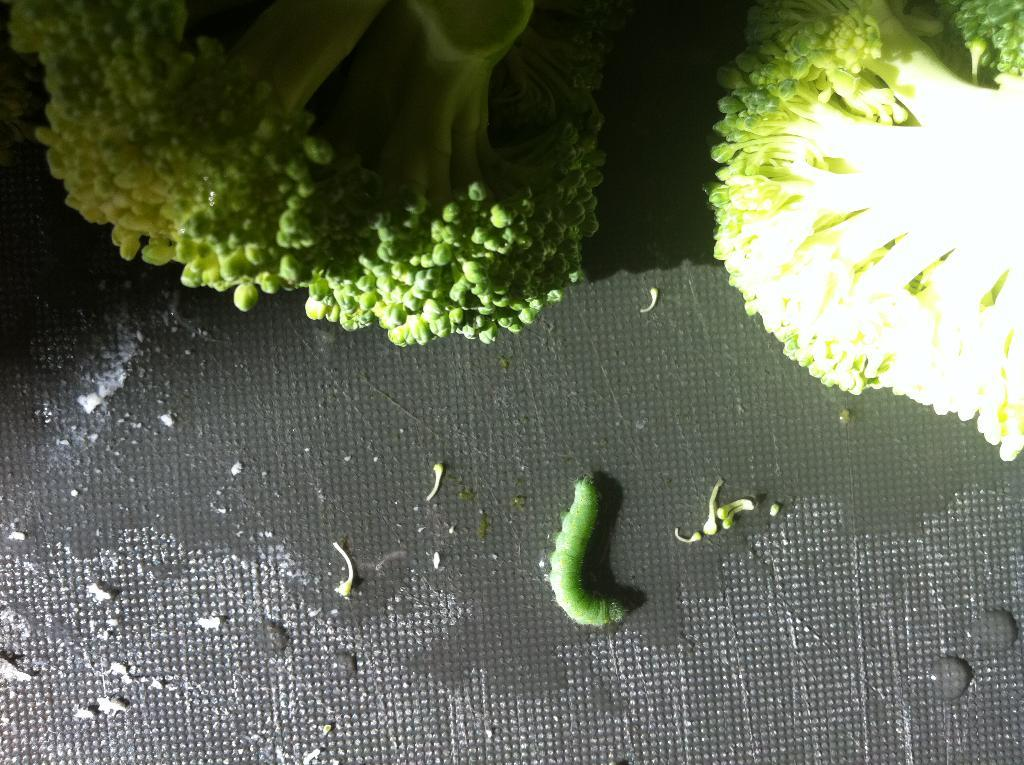What type of creature is present in the image? There is an insect in the image. What color is the insect? The insect is green in color. Where is the insect located in the image? The insect is on a surface. What type of vegetable can be seen in the image? There is broccoli in the image. How many slaves are visible in the image? There are no slaves present in the image. What type of hill can be seen in the background of the image? There is no hill visible in the image. 